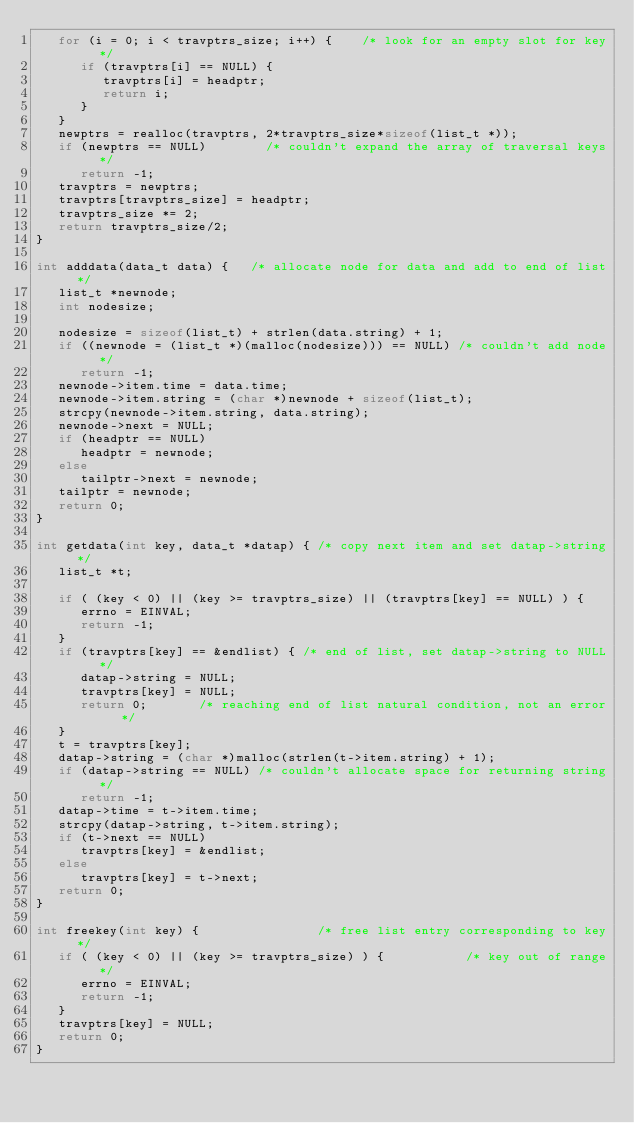Convert code to text. <code><loc_0><loc_0><loc_500><loc_500><_C_>   for (i = 0; i < travptrs_size; i++) {    /* look for an empty slot for key */
      if (travptrs[i] == NULL) {
         travptrs[i] = headptr;
         return i;
      }
   }
   newptrs = realloc(travptrs, 2*travptrs_size*sizeof(list_t *));
   if (newptrs == NULL)        /* couldn't expand the array of traversal keys */
      return -1;
   travptrs = newptrs;
   travptrs[travptrs_size] = headptr;
   travptrs_size *= 2;
   return travptrs_size/2;
}

int adddata(data_t data) {   /* allocate node for data and add to end of list */
   list_t *newnode;
   int nodesize;
 
   nodesize = sizeof(list_t) + strlen(data.string) + 1;
   if ((newnode = (list_t *)(malloc(nodesize))) == NULL) /* couldn't add node */
      return -1;
   newnode->item.time = data.time;
   newnode->item.string = (char *)newnode + sizeof(list_t);
   strcpy(newnode->item.string, data.string);
   newnode->next = NULL;
   if (headptr == NULL)
      headptr = newnode;
   else 
      tailptr->next = newnode;
   tailptr = newnode;
   return 0;
}
 
int getdata(int key, data_t *datap) { /* copy next item and set datap->string */
   list_t *t;    
 
   if ( (key < 0) || (key >= travptrs_size) || (travptrs[key] == NULL) ) {
      errno = EINVAL;
      return -1;
   }
   if (travptrs[key] == &endlist) { /* end of list, set datap->string to NULL */
      datap->string = NULL;
      travptrs[key] = NULL;
      return 0;       /* reaching end of list natural condition, not an error */           
   }
   t = travptrs[key];
   datap->string = (char *)malloc(strlen(t->item.string) + 1);
   if (datap->string == NULL) /* couldn't allocate space for returning string */
      return -1;
   datap->time = t->item.time;
   strcpy(datap->string, t->item.string);
   if (t->next == NULL)
      travptrs[key] = &endlist;
   else
      travptrs[key] = t->next;
   return 0;
}

int freekey(int key) {                /* free list entry corresponding to key */
   if ( (key < 0) || (key >= travptrs_size) ) {           /* key out of range */
      errno = EINVAL;
      return -1;
   }
   travptrs[key] = NULL;
   return 0;
}
</code> 